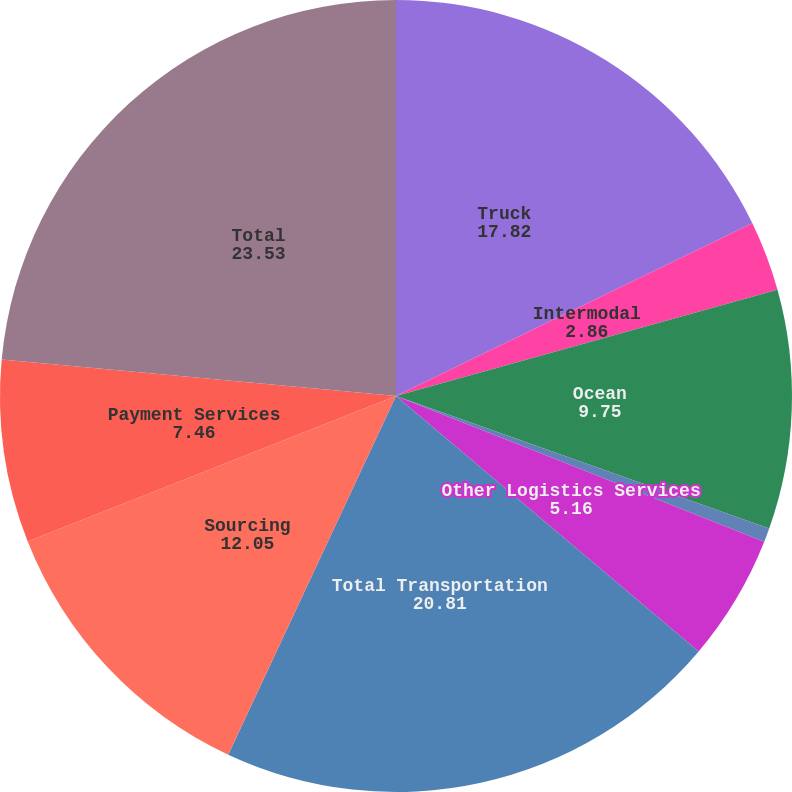Convert chart to OTSL. <chart><loc_0><loc_0><loc_500><loc_500><pie_chart><fcel>Truck<fcel>Intermodal<fcel>Ocean<fcel>Air<fcel>Other Logistics Services<fcel>Total Transportation<fcel>Sourcing<fcel>Payment Services<fcel>Total<nl><fcel>17.82%<fcel>2.86%<fcel>9.75%<fcel>0.57%<fcel>5.16%<fcel>20.81%<fcel>12.05%<fcel>7.46%<fcel>23.53%<nl></chart> 